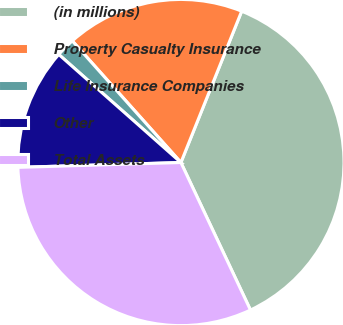<chart> <loc_0><loc_0><loc_500><loc_500><pie_chart><fcel>(in millions)<fcel>Property Casualty Insurance<fcel>Life Insurance Companies<fcel>Other<fcel>Total Assets<nl><fcel>36.91%<fcel>17.68%<fcel>1.87%<fcel>12.0%<fcel>31.54%<nl></chart> 